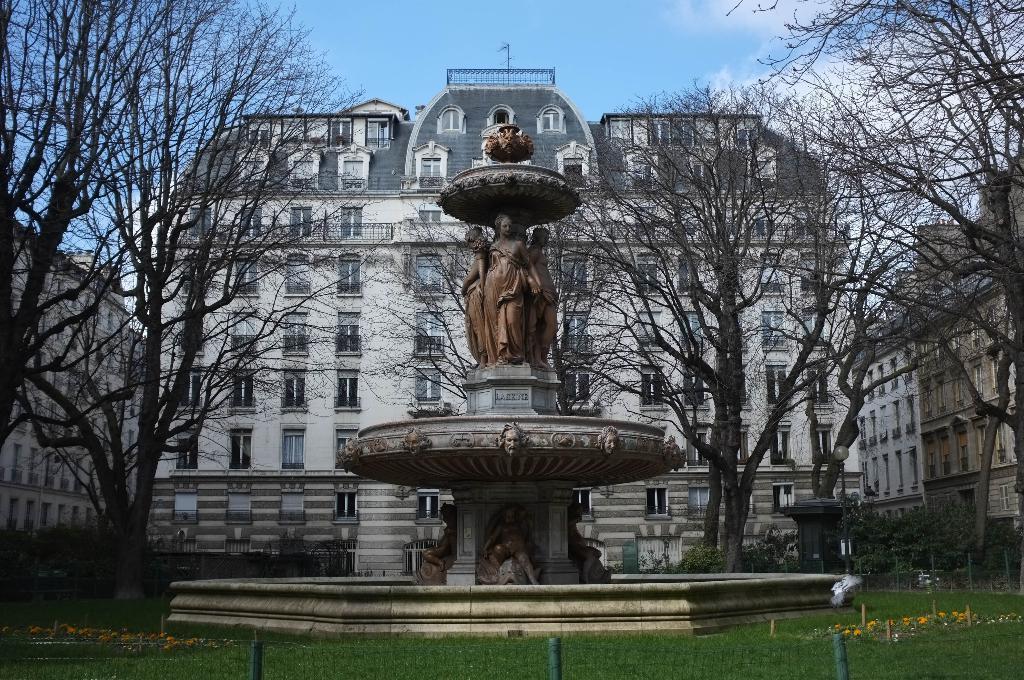How would you summarize this image in a sentence or two? There is a sculpture, fencing, grass, trees and buildings at the back. 